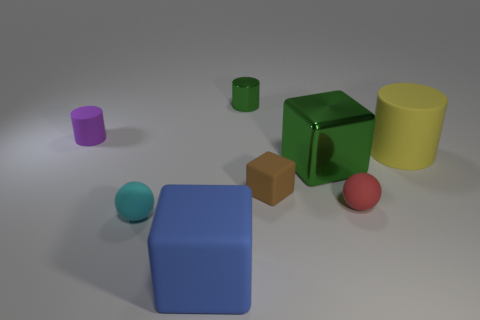Add 1 small balls. How many objects exist? 9 Subtract all balls. How many objects are left? 6 Subtract all purple cubes. Subtract all cyan rubber things. How many objects are left? 7 Add 1 small rubber spheres. How many small rubber spheres are left? 3 Add 7 large shiny objects. How many large shiny objects exist? 8 Subtract 1 green cylinders. How many objects are left? 7 